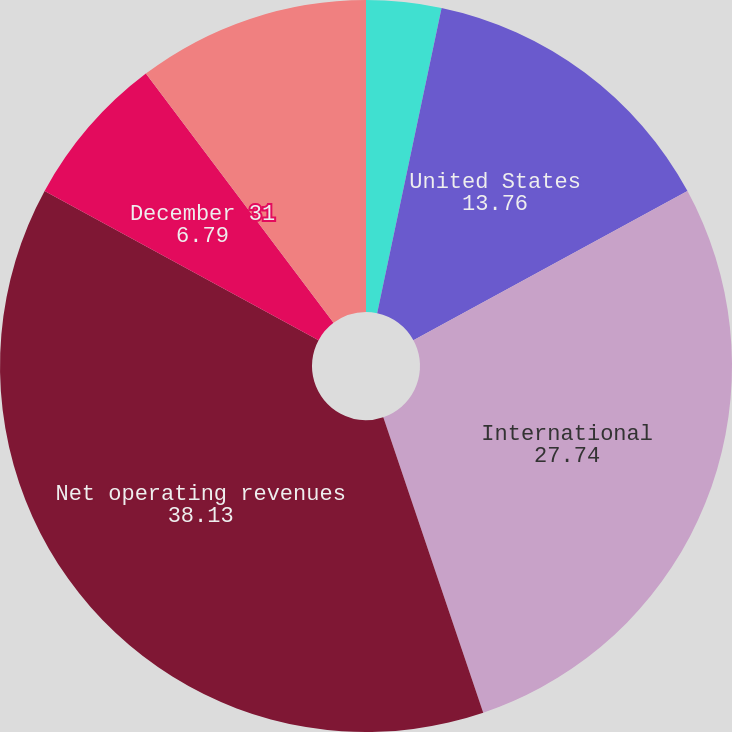Convert chart to OTSL. <chart><loc_0><loc_0><loc_500><loc_500><pie_chart><fcel>Year Ended December 31<fcel>United States<fcel>International<fcel>Net operating revenues<fcel>December 31<fcel>Property plant and<nl><fcel>3.31%<fcel>13.76%<fcel>27.74%<fcel>38.13%<fcel>6.79%<fcel>10.27%<nl></chart> 